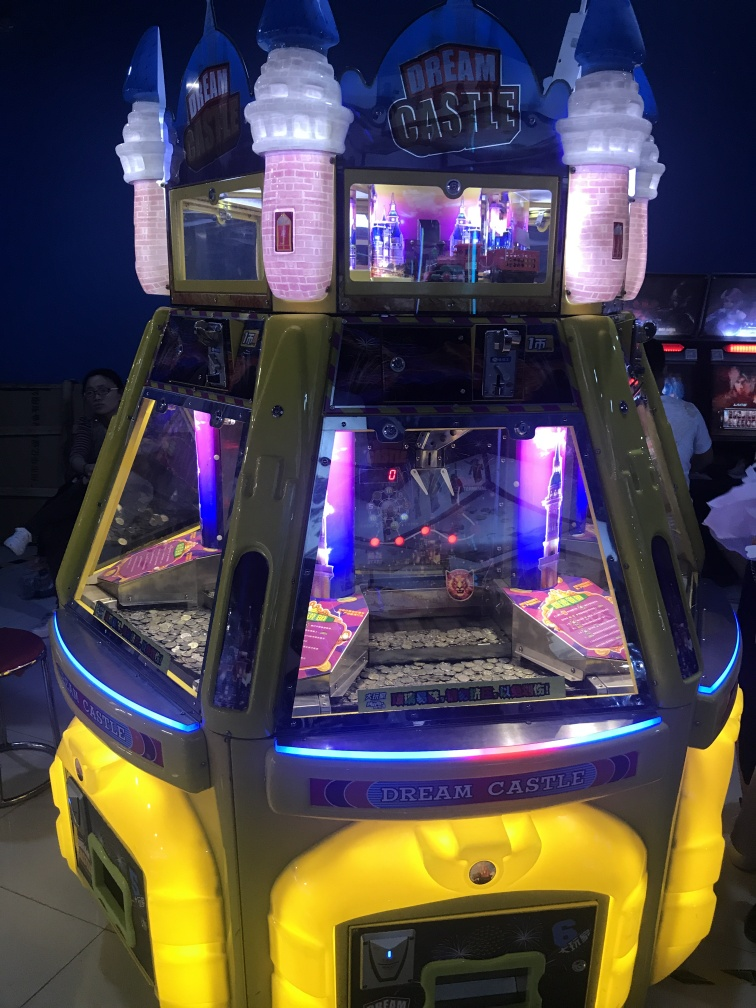How does the lighting in the photo influence the mood or attractiveness of the arcade game? The lighting in the photo enhances the mood by creating a lively and magical atmosphere. The glowing neon lights and illuminated towers invite excitement, suggesting a fun and enchanting experience. This lighting can make the arcade game more attractive, especially to children and families seeking entertainment. What role might colors play in the design of arcade games as seen in the photo? Colors play a crucial role in the design of arcade games by attracting attention, conveying themes, and influencing emotions. In the photo, bright yellows, purples, and pinks evoke a sense of joy and whimsy, which are key to creating an engaging environment for players. The contrasting colors also make the game stand out, helping it to catch the eye of potential players in a crowded arcade. 